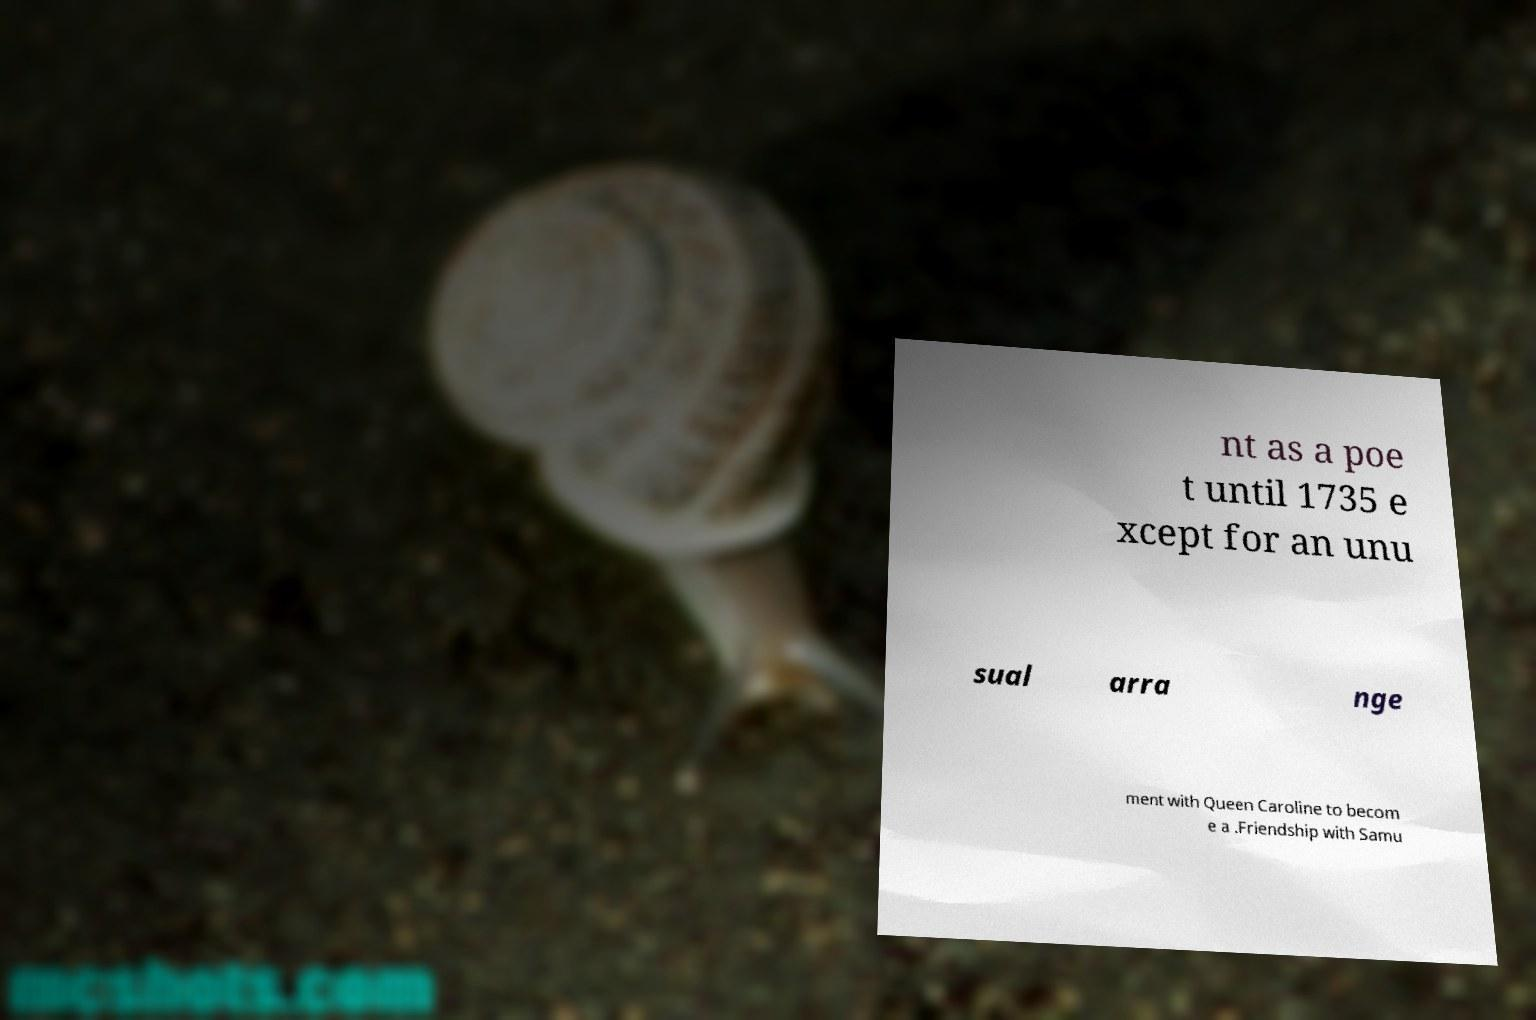For documentation purposes, I need the text within this image transcribed. Could you provide that? nt as a poe t until 1735 e xcept for an unu sual arra nge ment with Queen Caroline to becom e a .Friendship with Samu 